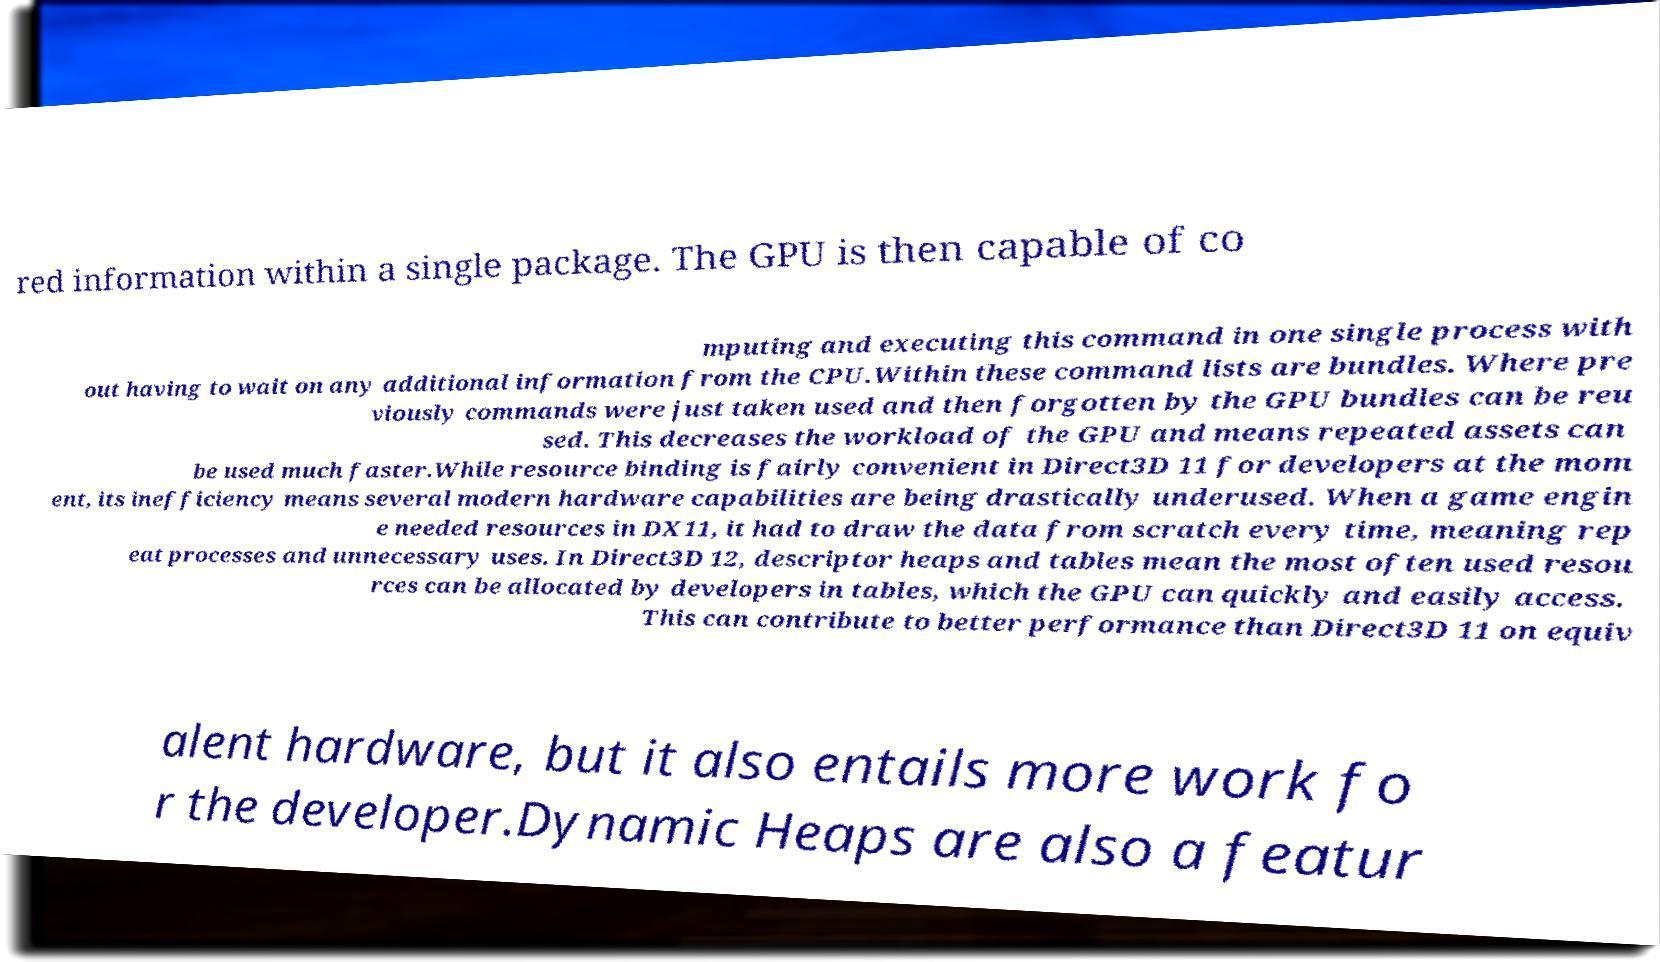There's text embedded in this image that I need extracted. Can you transcribe it verbatim? red information within a single package. The GPU is then capable of co mputing and executing this command in one single process with out having to wait on any additional information from the CPU.Within these command lists are bundles. Where pre viously commands were just taken used and then forgotten by the GPU bundles can be reu sed. This decreases the workload of the GPU and means repeated assets can be used much faster.While resource binding is fairly convenient in Direct3D 11 for developers at the mom ent, its inefficiency means several modern hardware capabilities are being drastically underused. When a game engin e needed resources in DX11, it had to draw the data from scratch every time, meaning rep eat processes and unnecessary uses. In Direct3D 12, descriptor heaps and tables mean the most often used resou rces can be allocated by developers in tables, which the GPU can quickly and easily access. This can contribute to better performance than Direct3D 11 on equiv alent hardware, but it also entails more work fo r the developer.Dynamic Heaps are also a featur 